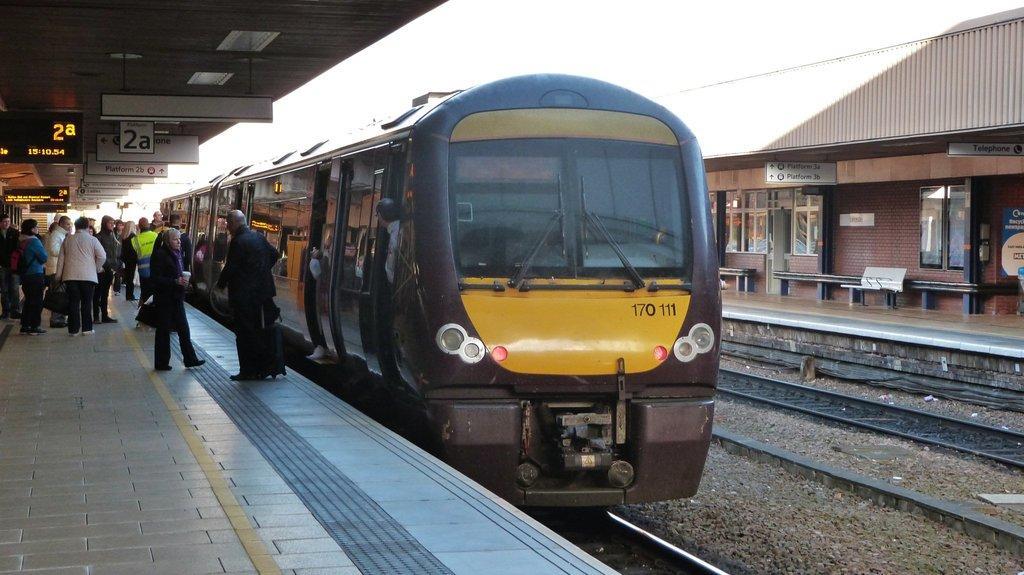How would you summarize this image in a sentence or two? In the picture there is a train on the railway track, beside the train there many tracks present, there is a platform, there are people present, there are many boards with the text, there are many benches, there is a clear sky. 